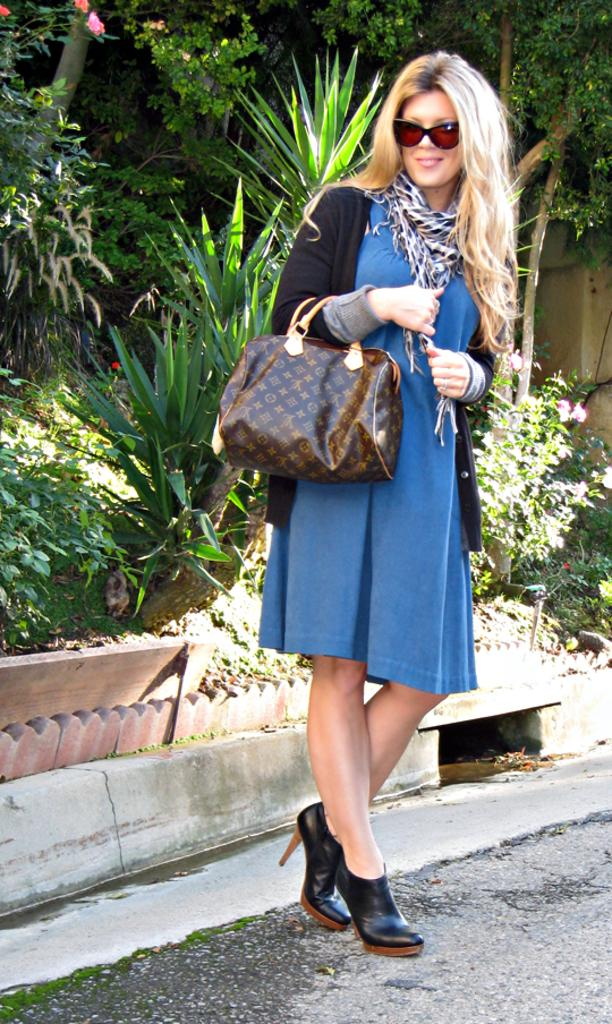What is the woman in the image doing? The woman is standing on the road. What can be seen in the background of the image? There are trees visible in the background. What type of cherry is the woman holding in the image? There is no cherry present in the image. What kind of record can be heard playing in the background? There is no record or sound present in the image. 